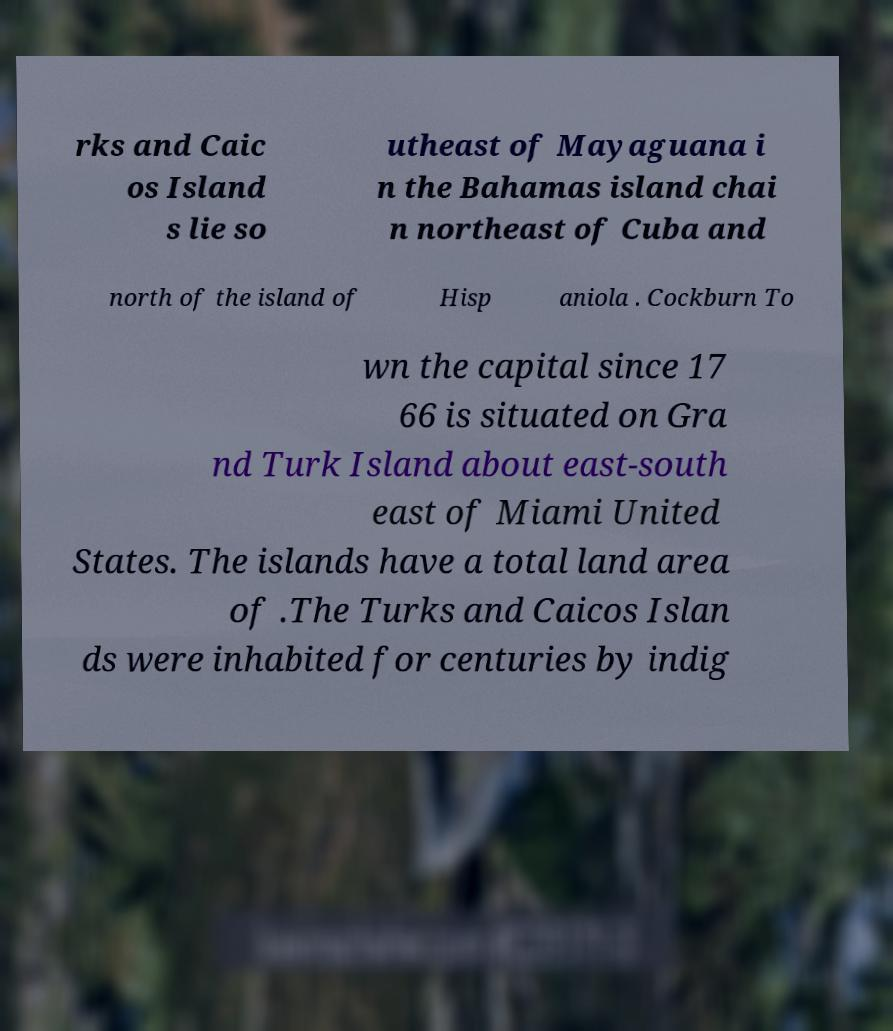There's text embedded in this image that I need extracted. Can you transcribe it verbatim? rks and Caic os Island s lie so utheast of Mayaguana i n the Bahamas island chai n northeast of Cuba and north of the island of Hisp aniola . Cockburn To wn the capital since 17 66 is situated on Gra nd Turk Island about east-south east of Miami United States. The islands have a total land area of .The Turks and Caicos Islan ds were inhabited for centuries by indig 